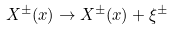<formula> <loc_0><loc_0><loc_500><loc_500>X ^ { \pm } ( x ) \rightarrow X ^ { \pm } ( x ) + \xi ^ { \pm }</formula> 